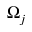Convert formula to latex. <formula><loc_0><loc_0><loc_500><loc_500>\Omega _ { j }</formula> 